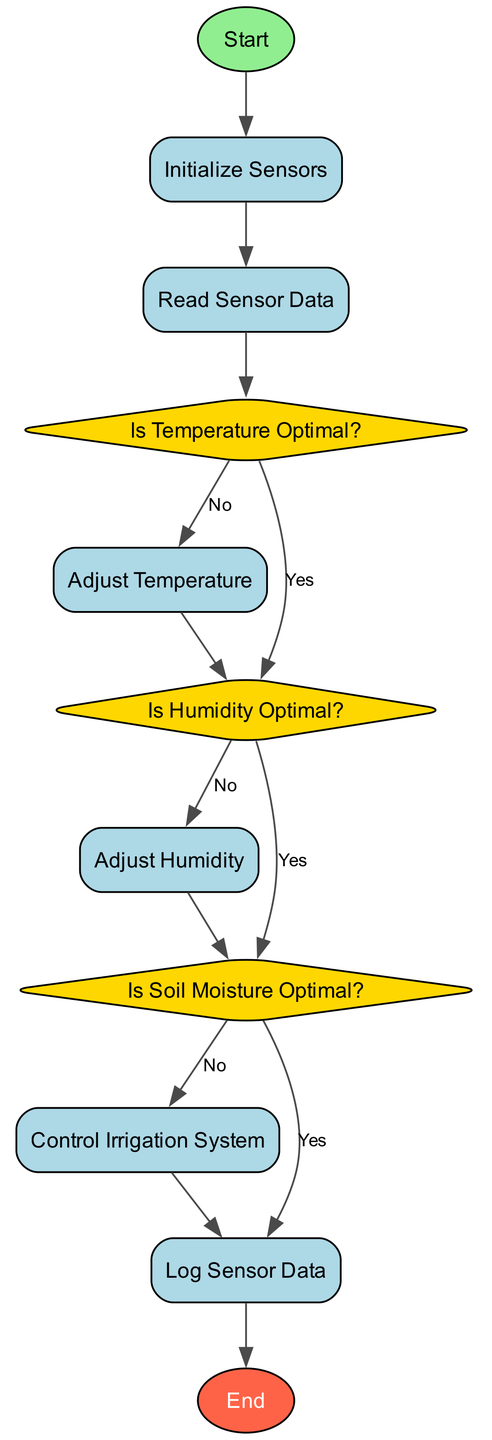What is the first step in the diagram? The diagram starts with the "Start" node, which indicates the beginning of the automated greenhouse climate control process.
Answer: Start How many decision nodes are present in the diagram? There are three decision nodes: "Is Temperature Optimal?", "Is Humidity Optimal?", and "Is Soil Moisture Optimal?".
Answer: Three What action is taken if the temperature is not optimal? If the temperature is not optimal, the "Adjust Temperature" process is executed to modify the temperature conditions.
Answer: Adjust Temperature Which process follows after verifying soil moisture? After checking soil moisture, if it is not optimal, the "Control Irrigation System" process is initiated to manage water levels.
Answer: Control Irrigation System What happens if humidity is optimal? If humidity is optimal, the flow continues to the next decision node, where soil moisture is then checked.
Answer: Check Soil Moisture How many times is the "Log Sensor Data" process executed? The "Log Sensor Data" process is executed once after either checking soil moisture or controlling the irrigation system, depending on the conditions met.
Answer: Once What does the diamond shape represent in this flowchart? The diamond shapes in the flowchart represent decision points where a choice based on conditions is made.
Answer: Decision Points What is the final step of the process? The final step in this flowchart is marked by the "End" node, which signifies the conclusion of the automated greenhouse climate control procedure.
Answer: End 